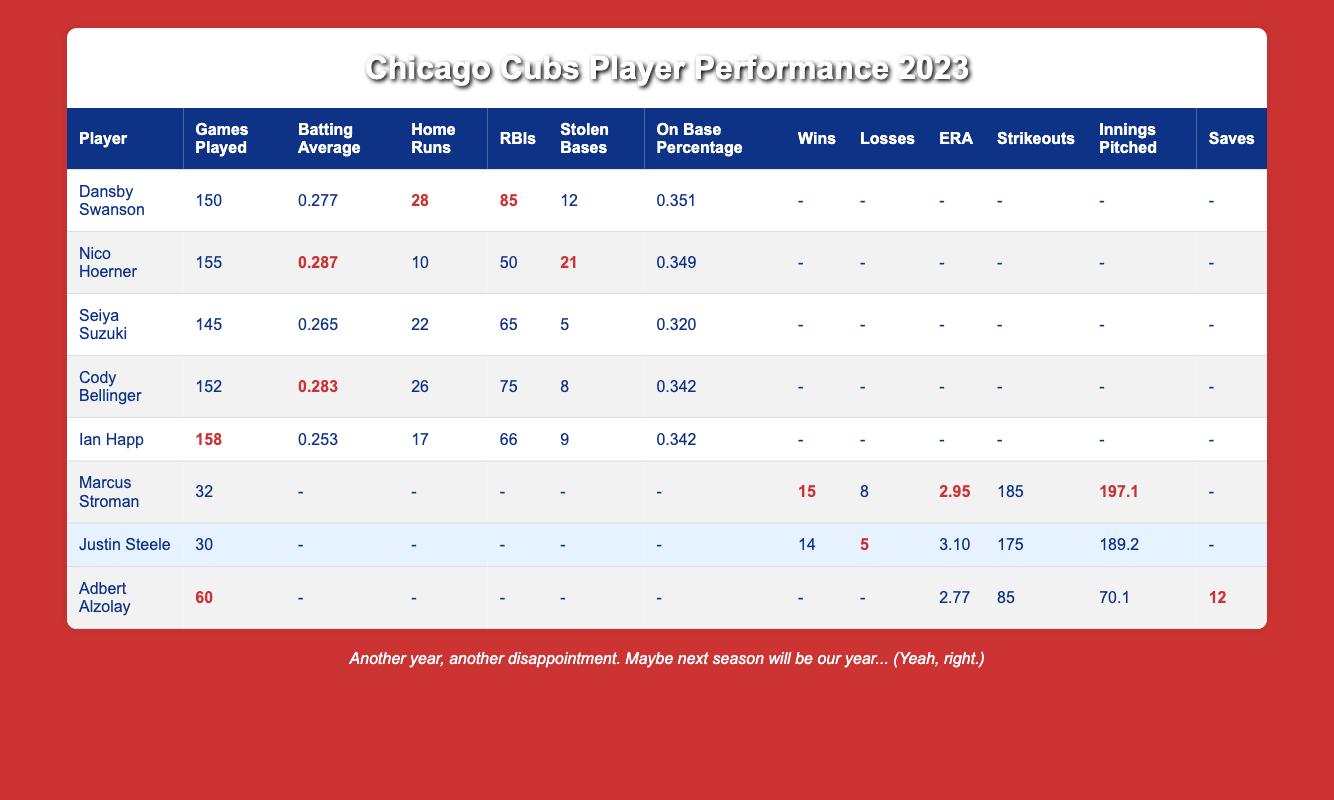What is Dansby Swanson's batting average? Dansby Swanson's batting average is provided in the table. It's the column labeled "Batting Average" next to his name, which shows a value of 0.277.
Answer: 0.277 Who played the most games in the 2023 season? The table shows the "Games Played" for each player. Ian Happ played the most games at 158, which is the highest value in that column.
Answer: 158 How many home runs did Cody Bellinger hit? Cody Bellinger’s home runs can be found in the “Home Runs” column. His row shows a value of 26.
Answer: 26 What is the total number of RBIs (Runs Batted In) for the three players: Dansby Swanson, Cody Bellinger, and Seiya Suzuki? To find the total RBIs, we add the values from the three players: 85 (Swanson) + 75 (Bellinger) + 65 (Suzuki) = 225.
Answer: 225 Did Nico Hoerner have more than 20 stolen bases? By looking at the "Stolen Bases" column for Nico Hoerner, we see that he had 21 stolen bases, which is indeed greater than 20.
Answer: Yes What is the average batting average of the players mentioned in the table? The batting averages of the players are 0.277, 0.287, 0.265, 0.283, and 0.253. To find the average, sum these values (0.277 + 0.287 + 0.265 + 0.283 + 0.253 = 1.365) and divide by the number of players (5), which gives: 1.365 / 5 = 0.273.
Answer: 0.273 Which player has the lowest earned run average (ERA) among the pitchers? The "ERA" column shows values for Marcus Stroman (2.95), Justin Steele (3.10), and Adbert Alzolay (2.77). The lowest is 2.77 for Adbert Alzolay.
Answer: 2.77 How many strikeouts did Marcus Stroman achieve? The "Strikeouts" column under Marcus Stroman indicates he achieved 185 strikeouts.
Answer: 185 What is the combined number of wins for Stroman and Steele? We add the wins for both players: 15 (Stroman) + 14 (Steele) = 29.
Answer: 29 Did any player have a batting average over 0.280? In the table, we look at the "Batting Average" column and see that Dansby Swanson (0.277), Cody Bellinger (0.283), and Nico Hoerner (0.287) have averages above 0.280.
Answer: Yes Which player had the most stolen bases? The "Stolen Bases" column shows that Nico Hoerner had the most with 21.
Answer: 21 